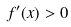Convert formula to latex. <formula><loc_0><loc_0><loc_500><loc_500>f ^ { \prime } ( x ) > 0</formula> 